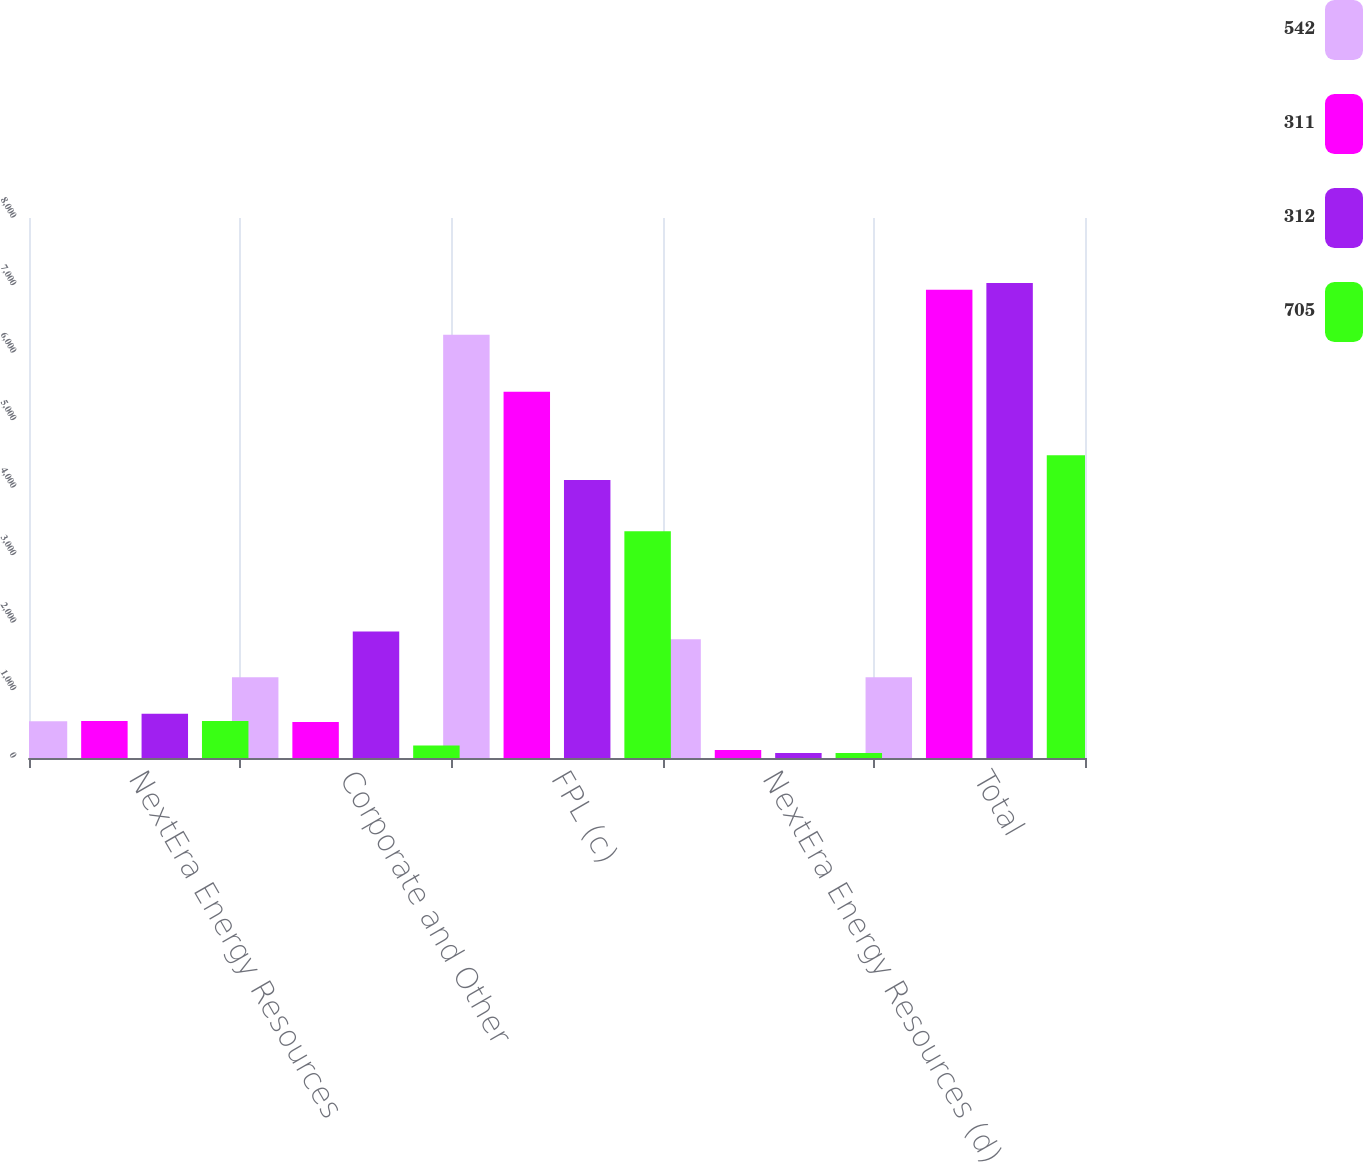<chart> <loc_0><loc_0><loc_500><loc_500><stacked_bar_chart><ecel><fcel>NextEra Energy Resources<fcel>Corporate and Other<fcel>FPL (c)<fcel>NextEra Energy Resources (d)<fcel>Total<nl><fcel>542<fcel>544<fcel>1195<fcel>6270<fcel>1760<fcel>1195<nl><fcel>311<fcel>549<fcel>533<fcel>5425<fcel>120<fcel>6938<nl><fcel>312<fcel>656<fcel>1874<fcel>4120<fcel>75<fcel>7037<nl><fcel>705<fcel>548<fcel>187<fcel>3360<fcel>75<fcel>4486<nl></chart> 